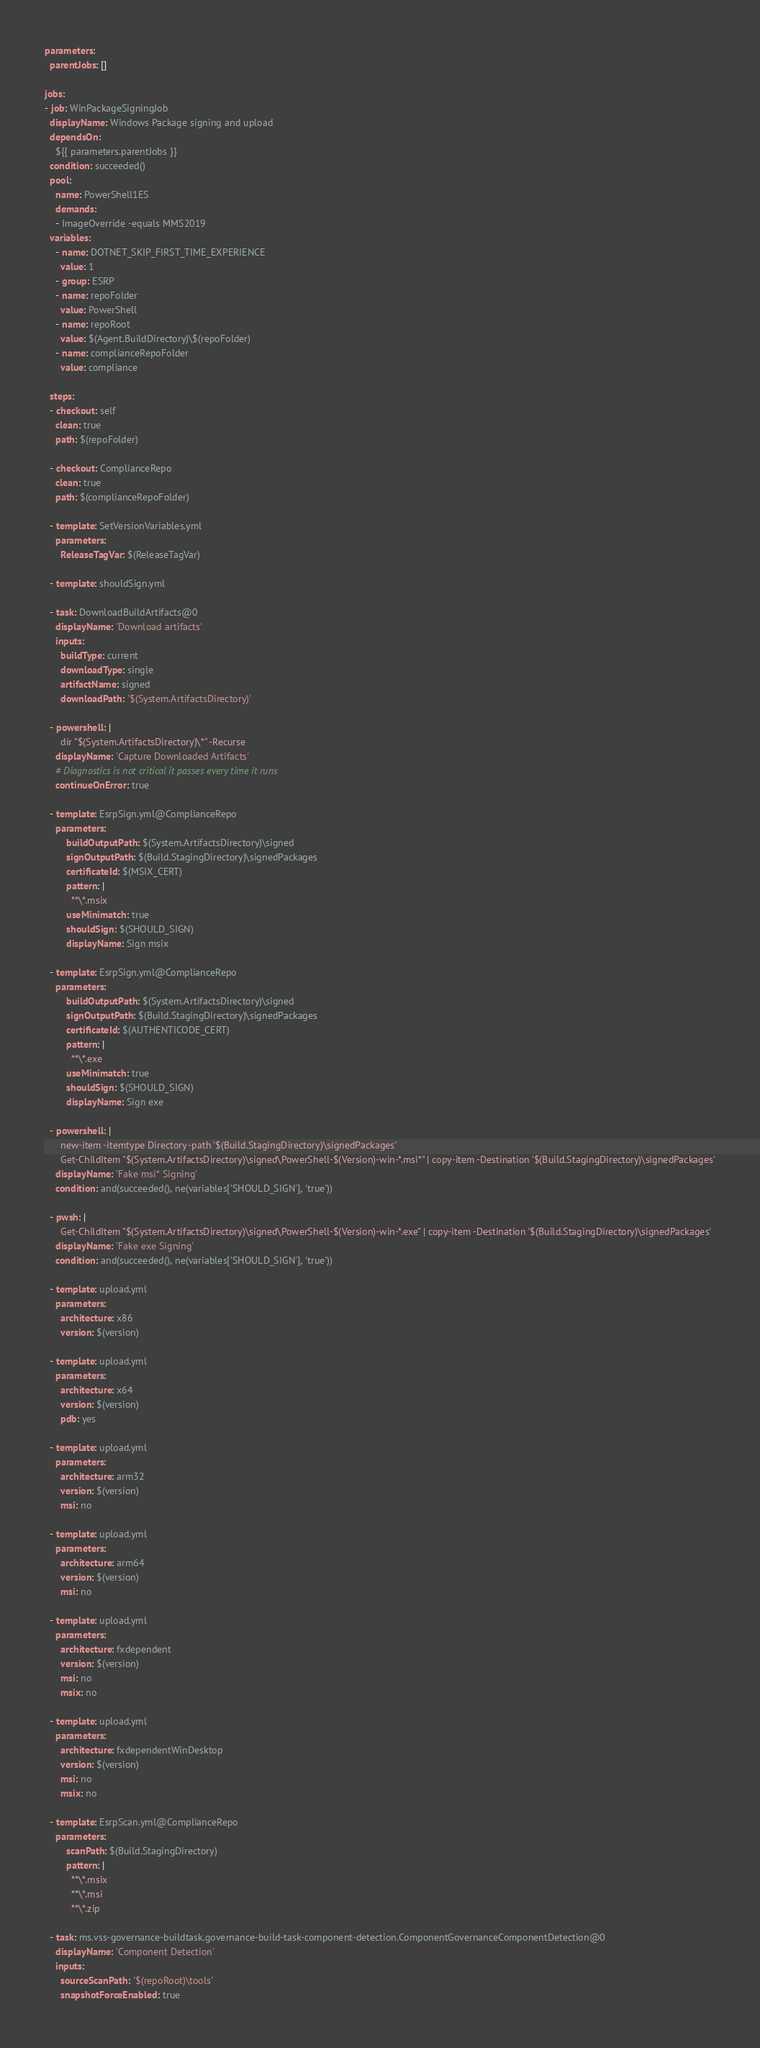<code> <loc_0><loc_0><loc_500><loc_500><_YAML_>parameters:
  parentJobs: []

jobs:
- job: WinPackageSigningJob
  displayName: Windows Package signing and upload
  dependsOn:
    ${{ parameters.parentJobs }}
  condition: succeeded()
  pool:
    name: PowerShell1ES
    demands:
    - ImageOverride -equals MMS2019
  variables:
    - name: DOTNET_SKIP_FIRST_TIME_EXPERIENCE
      value: 1
    - group: ESRP
    - name: repoFolder
      value: PowerShell
    - name: repoRoot
      value: $(Agent.BuildDirectory)\$(repoFolder)
    - name: complianceRepoFolder
      value: compliance

  steps:
  - checkout: self
    clean: true
    path: $(repoFolder)

  - checkout: ComplianceRepo
    clean: true
    path: $(complianceRepoFolder)

  - template: SetVersionVariables.yml
    parameters:
      ReleaseTagVar: $(ReleaseTagVar)

  - template: shouldSign.yml

  - task: DownloadBuildArtifacts@0
    displayName: 'Download artifacts'
    inputs:
      buildType: current
      downloadType: single
      artifactName: signed
      downloadPath: '$(System.ArtifactsDirectory)'

  - powershell: |
      dir "$(System.ArtifactsDirectory)\*" -Recurse
    displayName: 'Capture Downloaded Artifacts'
    # Diagnostics is not critical it passes every time it runs
    continueOnError: true

  - template: EsrpSign.yml@ComplianceRepo
    parameters:
        buildOutputPath: $(System.ArtifactsDirectory)\signed
        signOutputPath: $(Build.StagingDirectory)\signedPackages
        certificateId: $(MSIX_CERT)
        pattern: |
          **\*.msix
        useMinimatch: true
        shouldSign: $(SHOULD_SIGN)
        displayName: Sign msix

  - template: EsrpSign.yml@ComplianceRepo
    parameters:
        buildOutputPath: $(System.ArtifactsDirectory)\signed
        signOutputPath: $(Build.StagingDirectory)\signedPackages
        certificateId: $(AUTHENTICODE_CERT)
        pattern: |
          **\*.exe
        useMinimatch: true
        shouldSign: $(SHOULD_SIGN)
        displayName: Sign exe

  - powershell: |
      new-item -itemtype Directory -path '$(Build.StagingDirectory)\signedPackages'
      Get-ChildItem "$(System.ArtifactsDirectory)\signed\PowerShell-$(Version)-win-*.msi*" | copy-item -Destination '$(Build.StagingDirectory)\signedPackages'
    displayName: 'Fake msi* Signing'
    condition: and(succeeded(), ne(variables['SHOULD_SIGN'], 'true'))

  - pwsh: |
      Get-ChildItem "$(System.ArtifactsDirectory)\signed\PowerShell-$(Version)-win-*.exe" | copy-item -Destination '$(Build.StagingDirectory)\signedPackages'
    displayName: 'Fake exe Signing'
    condition: and(succeeded(), ne(variables['SHOULD_SIGN'], 'true'))

  - template: upload.yml
    parameters:
      architecture: x86
      version: $(version)

  - template: upload.yml
    parameters:
      architecture: x64
      version: $(version)
      pdb: yes

  - template: upload.yml
    parameters:
      architecture: arm32
      version: $(version)
      msi: no

  - template: upload.yml
    parameters:
      architecture: arm64
      version: $(version)
      msi: no

  - template: upload.yml
    parameters:
      architecture: fxdependent
      version: $(version)
      msi: no
      msix: no

  - template: upload.yml
    parameters:
      architecture: fxdependentWinDesktop
      version: $(version)
      msi: no
      msix: no

  - template: EsrpScan.yml@ComplianceRepo
    parameters:
        scanPath: $(Build.StagingDirectory)
        pattern: |
          **\*.msix
          **\*.msi
          **\*.zip

  - task: ms.vss-governance-buildtask.governance-build-task-component-detection.ComponentGovernanceComponentDetection@0
    displayName: 'Component Detection'
    inputs:
      sourceScanPath: '$(repoRoot)\tools'
      snapshotForceEnabled: true
</code> 